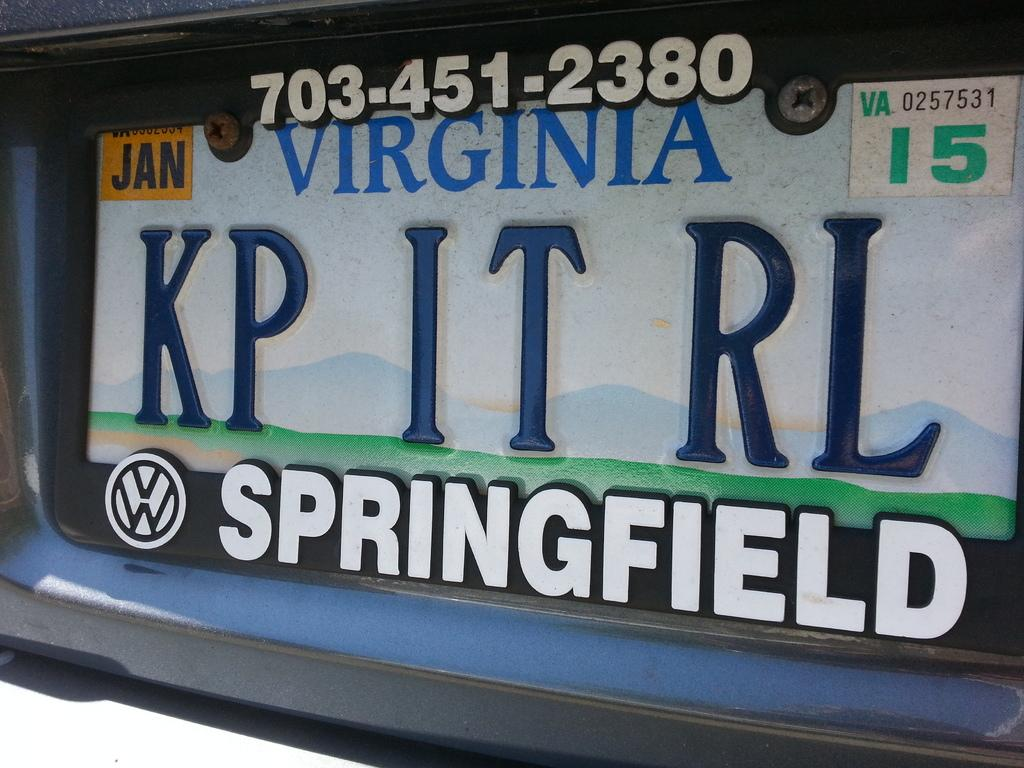<image>
Provide a brief description of the given image. license plates from the state of virginia  vw car 